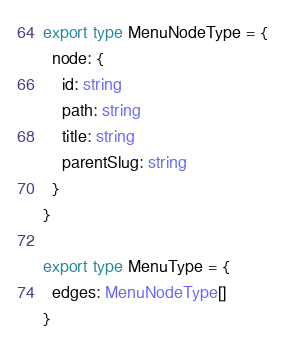<code> <loc_0><loc_0><loc_500><loc_500><_TypeScript_>export type MenuNodeType = {
  node: {
    id: string
    path: string
    title: string
    parentSlug: string
  }
}

export type MenuType = {
  edges: MenuNodeType[]
}
</code> 